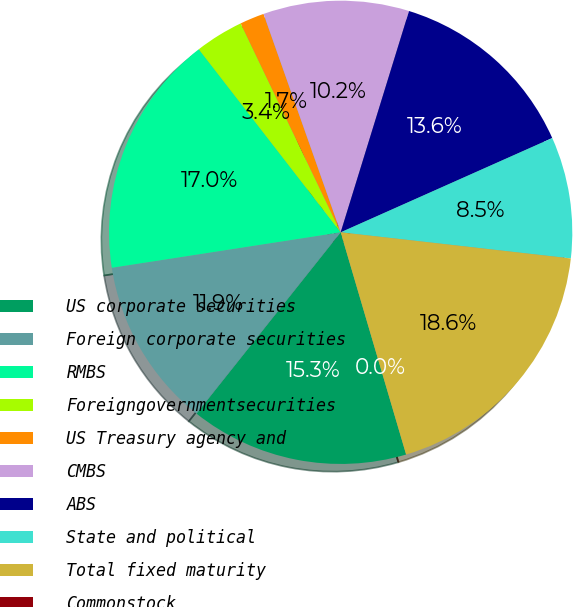Convert chart. <chart><loc_0><loc_0><loc_500><loc_500><pie_chart><fcel>US corporate securities<fcel>Foreign corporate securities<fcel>RMBS<fcel>Foreigngovernmentsecurities<fcel>US Treasury agency and<fcel>CMBS<fcel>ABS<fcel>State and political<fcel>Total fixed maturity<fcel>Commonstock<nl><fcel>15.25%<fcel>11.86%<fcel>16.95%<fcel>3.39%<fcel>1.7%<fcel>10.17%<fcel>13.56%<fcel>8.47%<fcel>18.64%<fcel>0.0%<nl></chart> 